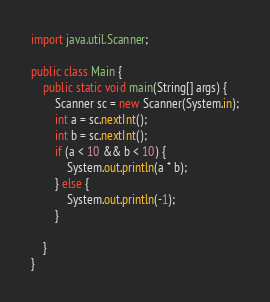<code> <loc_0><loc_0><loc_500><loc_500><_Java_>import java.util.Scanner;

public class Main {
	public static void main(String[] args) {
		Scanner sc = new Scanner(System.in);
		int a = sc.nextInt();
		int b = sc.nextInt();
		if (a < 10 && b < 10) {
			System.out.println(a * b);
		} else {
			System.out.println(-1);
		}

	}
}</code> 